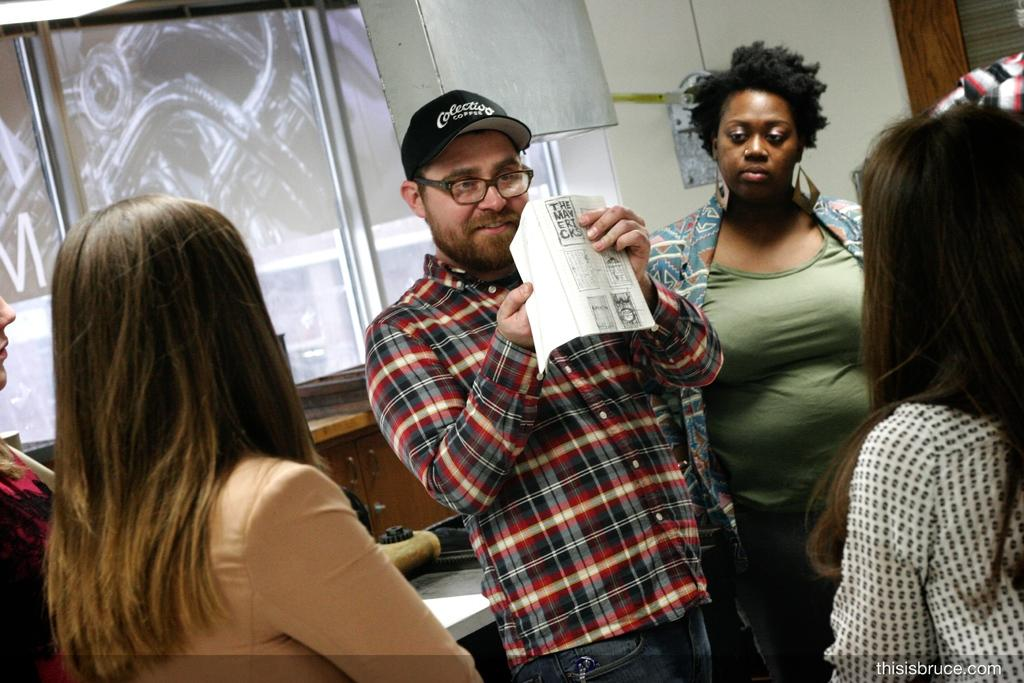How many people are present in the image? There are five persons in the image. What is one person doing with their hands? One person is holding a paper with their hands. Can you describe the appearance of the person holding the paper? The person holding the paper has spectacles and is wearing a cap. What can be seen in the background of the image? There is a board and a wall in the background of the image. What type of grape is being eaten by the person holding the paper? There is no grape present in the image, and the person holding the paper is not eating anything. How many teeth can be seen in the person's mouth while they are holding the paper? The image does not show the person's mouth, so it is not possible to determine how many teeth are visible. 